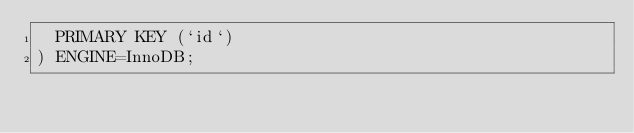Convert code to text. <code><loc_0><loc_0><loc_500><loc_500><_SQL_>  PRIMARY KEY (`id`)
) ENGINE=InnoDB;
</code> 